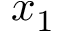<formula> <loc_0><loc_0><loc_500><loc_500>x _ { 1 }</formula> 